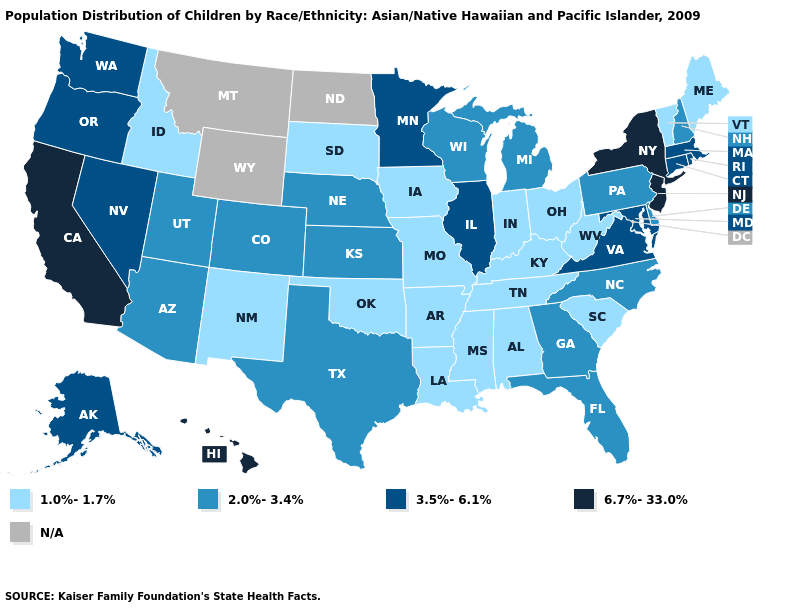What is the value of Maine?
Quick response, please. 1.0%-1.7%. What is the lowest value in the USA?
Quick response, please. 1.0%-1.7%. What is the value of South Carolina?
Quick response, please. 1.0%-1.7%. What is the highest value in the Northeast ?
Write a very short answer. 6.7%-33.0%. Among the states that border New Mexico , which have the lowest value?
Be succinct. Oklahoma. What is the value of North Carolina?
Write a very short answer. 2.0%-3.4%. What is the value of Massachusetts?
Short answer required. 3.5%-6.1%. What is the value of Georgia?
Answer briefly. 2.0%-3.4%. What is the value of Colorado?
Short answer required. 2.0%-3.4%. What is the lowest value in states that border Rhode Island?
Keep it brief. 3.5%-6.1%. Name the states that have a value in the range N/A?
Keep it brief. Montana, North Dakota, Wyoming. Is the legend a continuous bar?
Quick response, please. No. What is the value of New Jersey?
Answer briefly. 6.7%-33.0%. What is the value of California?
Concise answer only. 6.7%-33.0%. 